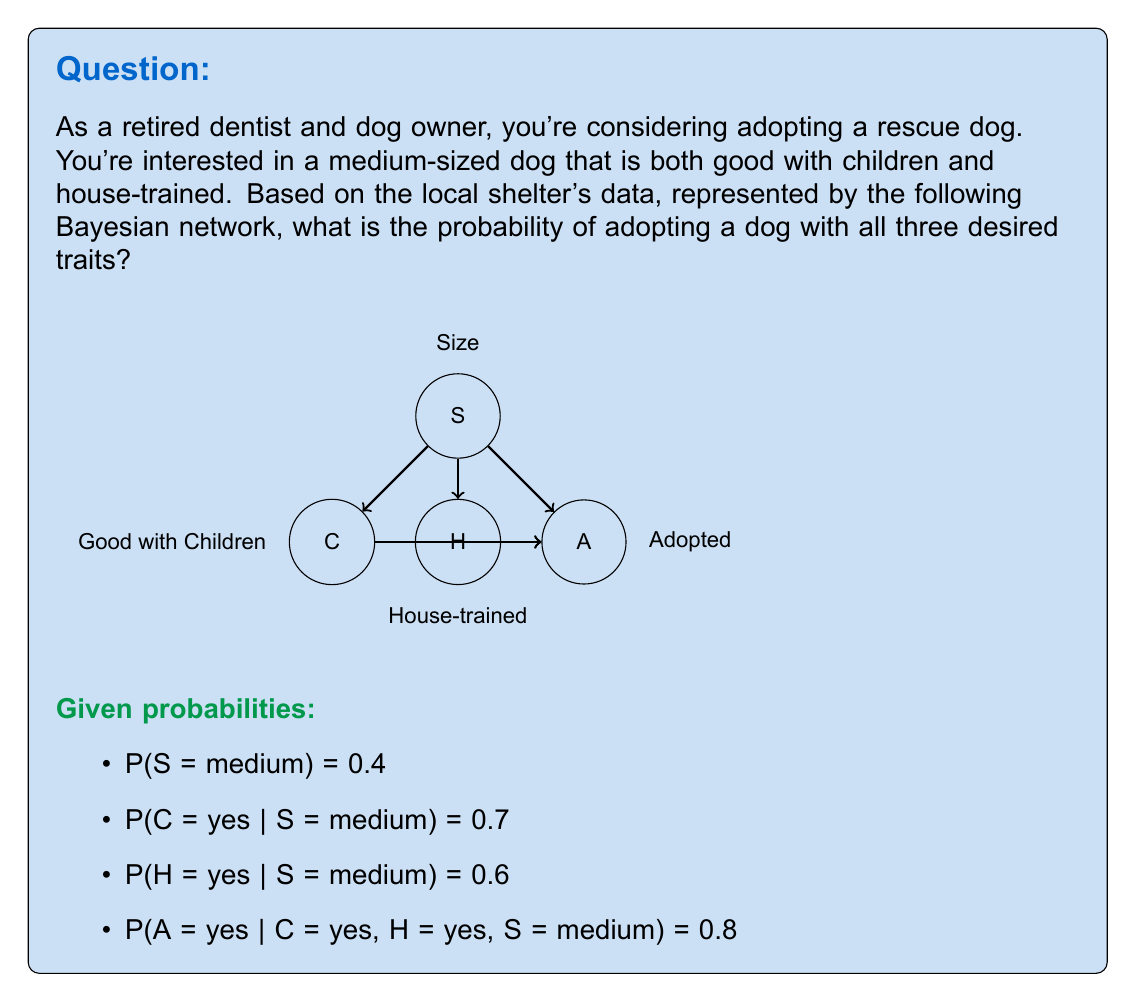Solve this math problem. To solve this problem, we'll use the chain rule of probability and the given Bayesian network structure.

Step 1: Define the event we're interested in
Let E be the event of adopting a medium-sized dog that is good with children and house-trained.

Step 2: Express the probability using the chain rule
$$P(E) = P(S = \text{medium}, C = \text{yes}, H = \text{yes}, A = \text{yes})$$
$$= P(A = \text{yes} | C = \text{yes}, H = \text{yes}, S = \text{medium}) \cdot P(C = \text{yes} | S = \text{medium}) \cdot P(H = \text{yes} | S = \text{medium}) \cdot P(S = \text{medium})$$

Step 3: Substitute the given probabilities
$$P(E) = 0.8 \cdot 0.7 \cdot 0.6 \cdot 0.4$$

Step 4: Calculate the final probability
$$P(E) = 0.8 \cdot 0.7 \cdot 0.6 \cdot 0.4 = 0.1344$$

Therefore, the probability of adopting a medium-sized dog that is good with children and house-trained is 0.1344 or 13.44%.
Answer: 0.1344 (or 13.44%) 